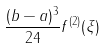Convert formula to latex. <formula><loc_0><loc_0><loc_500><loc_500>\frac { ( b - a ) ^ { 3 } } { 2 4 } f ^ { ( 2 ) } ( \xi )</formula> 